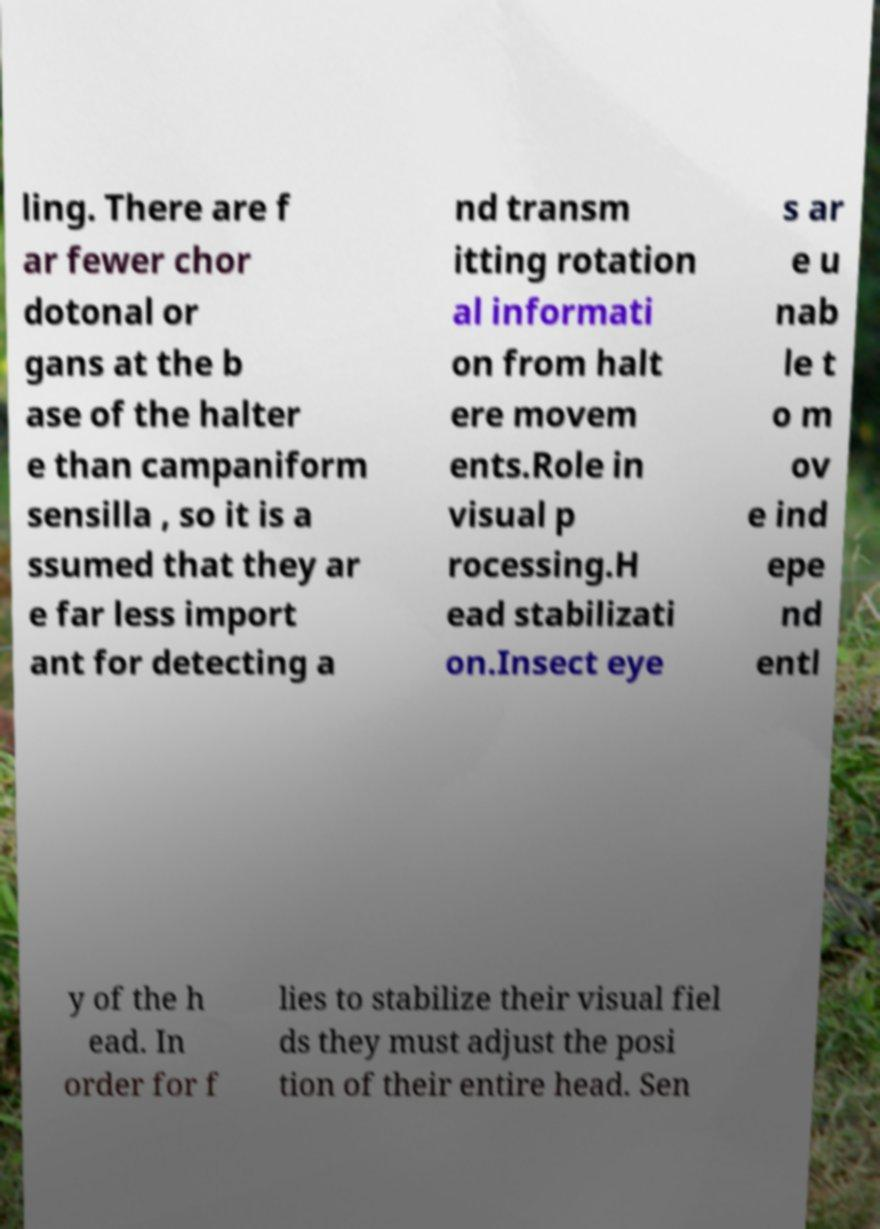For documentation purposes, I need the text within this image transcribed. Could you provide that? ling. There are f ar fewer chor dotonal or gans at the b ase of the halter e than campaniform sensilla , so it is a ssumed that they ar e far less import ant for detecting a nd transm itting rotation al informati on from halt ere movem ents.Role in visual p rocessing.H ead stabilizati on.Insect eye s ar e u nab le t o m ov e ind epe nd entl y of the h ead. In order for f lies to stabilize their visual fiel ds they must adjust the posi tion of their entire head. Sen 